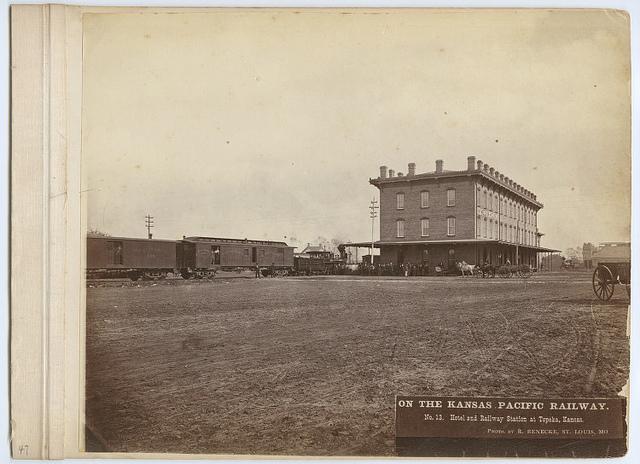Is there a place for people to sit?
Give a very brief answer. No. What word is seen on the picture?
Answer briefly. On kansas pacific railway. Is this a small or large building?
Concise answer only. Large. What Railway is photographed?
Write a very short answer. Kansas pacific railway. What does it say at the bottom of the photo?
Give a very brief answer. On kansas pacific railway. What is bellowing from the top of the train?
Short answer required. Smoke. Is this a recent photo?
Give a very brief answer. No. 